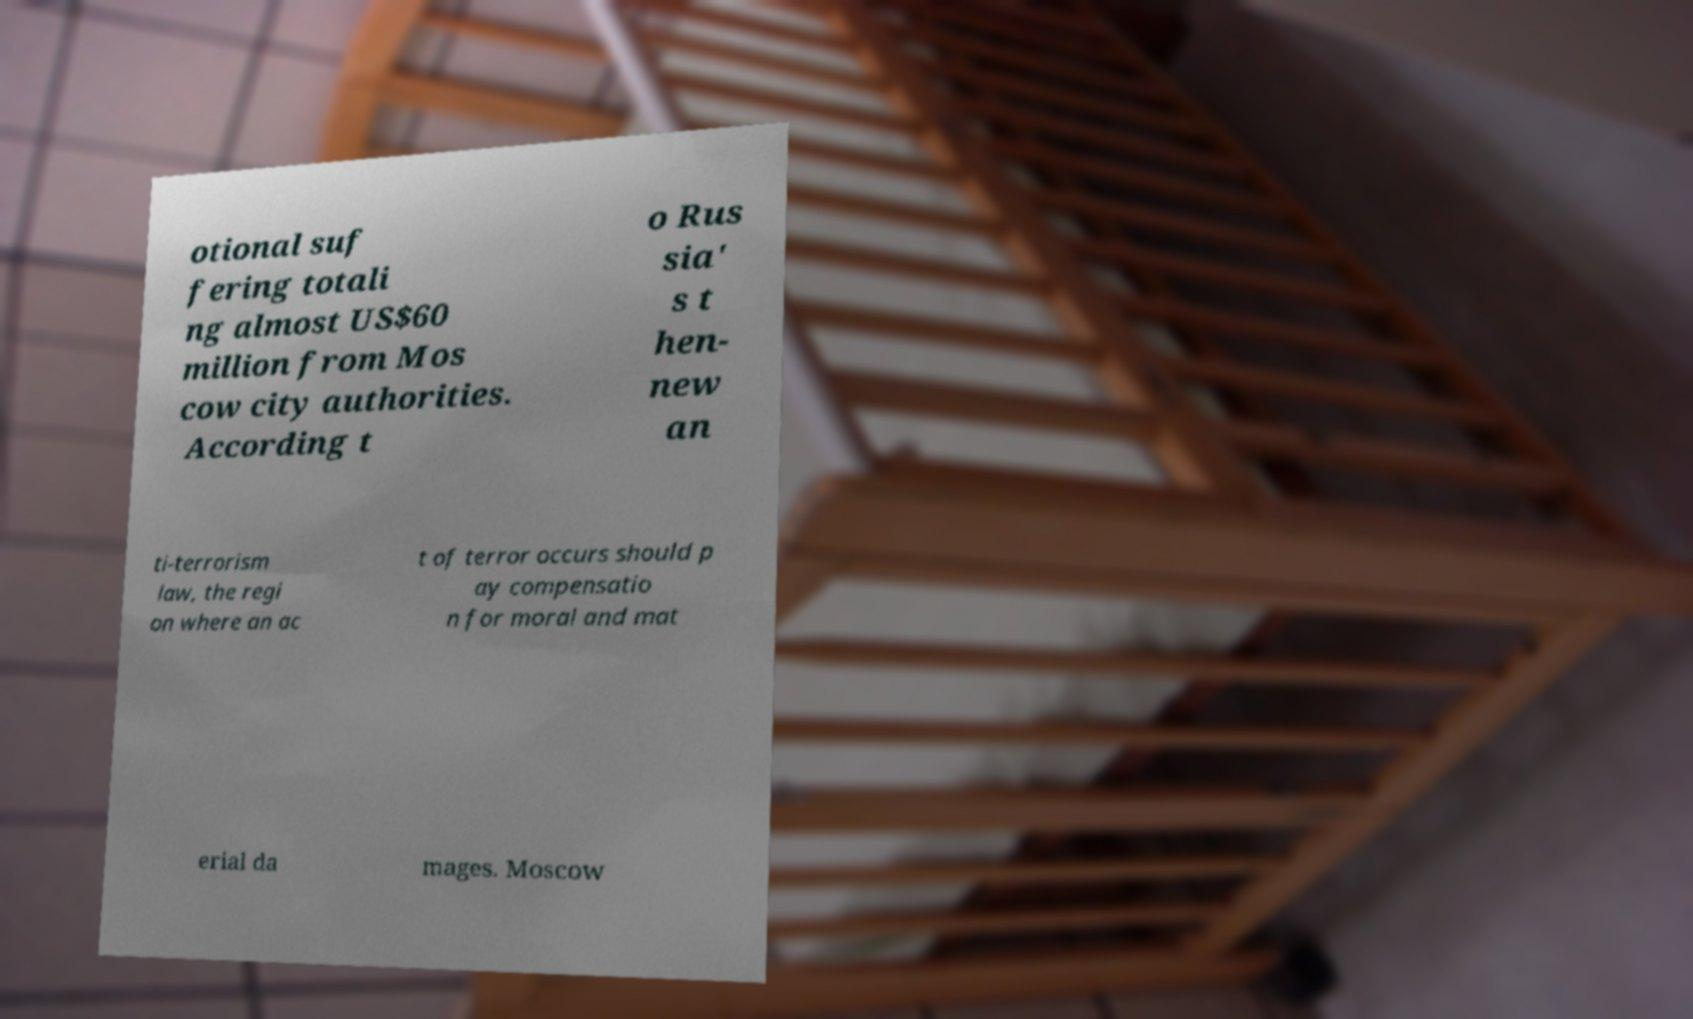I need the written content from this picture converted into text. Can you do that? otional suf fering totali ng almost US$60 million from Mos cow city authorities. According t o Rus sia' s t hen- new an ti-terrorism law, the regi on where an ac t of terror occurs should p ay compensatio n for moral and mat erial da mages. Moscow 